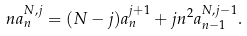<formula> <loc_0><loc_0><loc_500><loc_500>n a _ { n } ^ { N , j } = ( N - j ) a _ { n } ^ { j + 1 } + j n ^ { 2 } a _ { n - 1 } ^ { N , j - 1 } .</formula> 